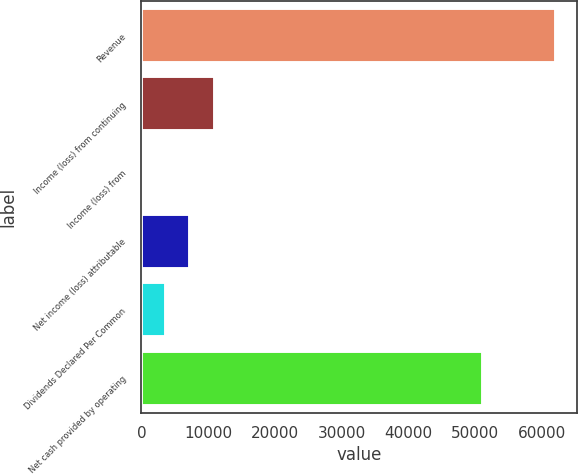Convert chart. <chart><loc_0><loc_0><loc_500><loc_500><bar_chart><fcel>Revenue<fcel>Income (loss) from continuing<fcel>Income (loss) from<fcel>Net income (loss) attributable<fcel>Dividends Declared Per Common<fcel>Net cash provided by operating<nl><fcel>62126.5<fcel>10963.5<fcel>0.01<fcel>7309.01<fcel>3654.51<fcel>51163<nl></chart> 